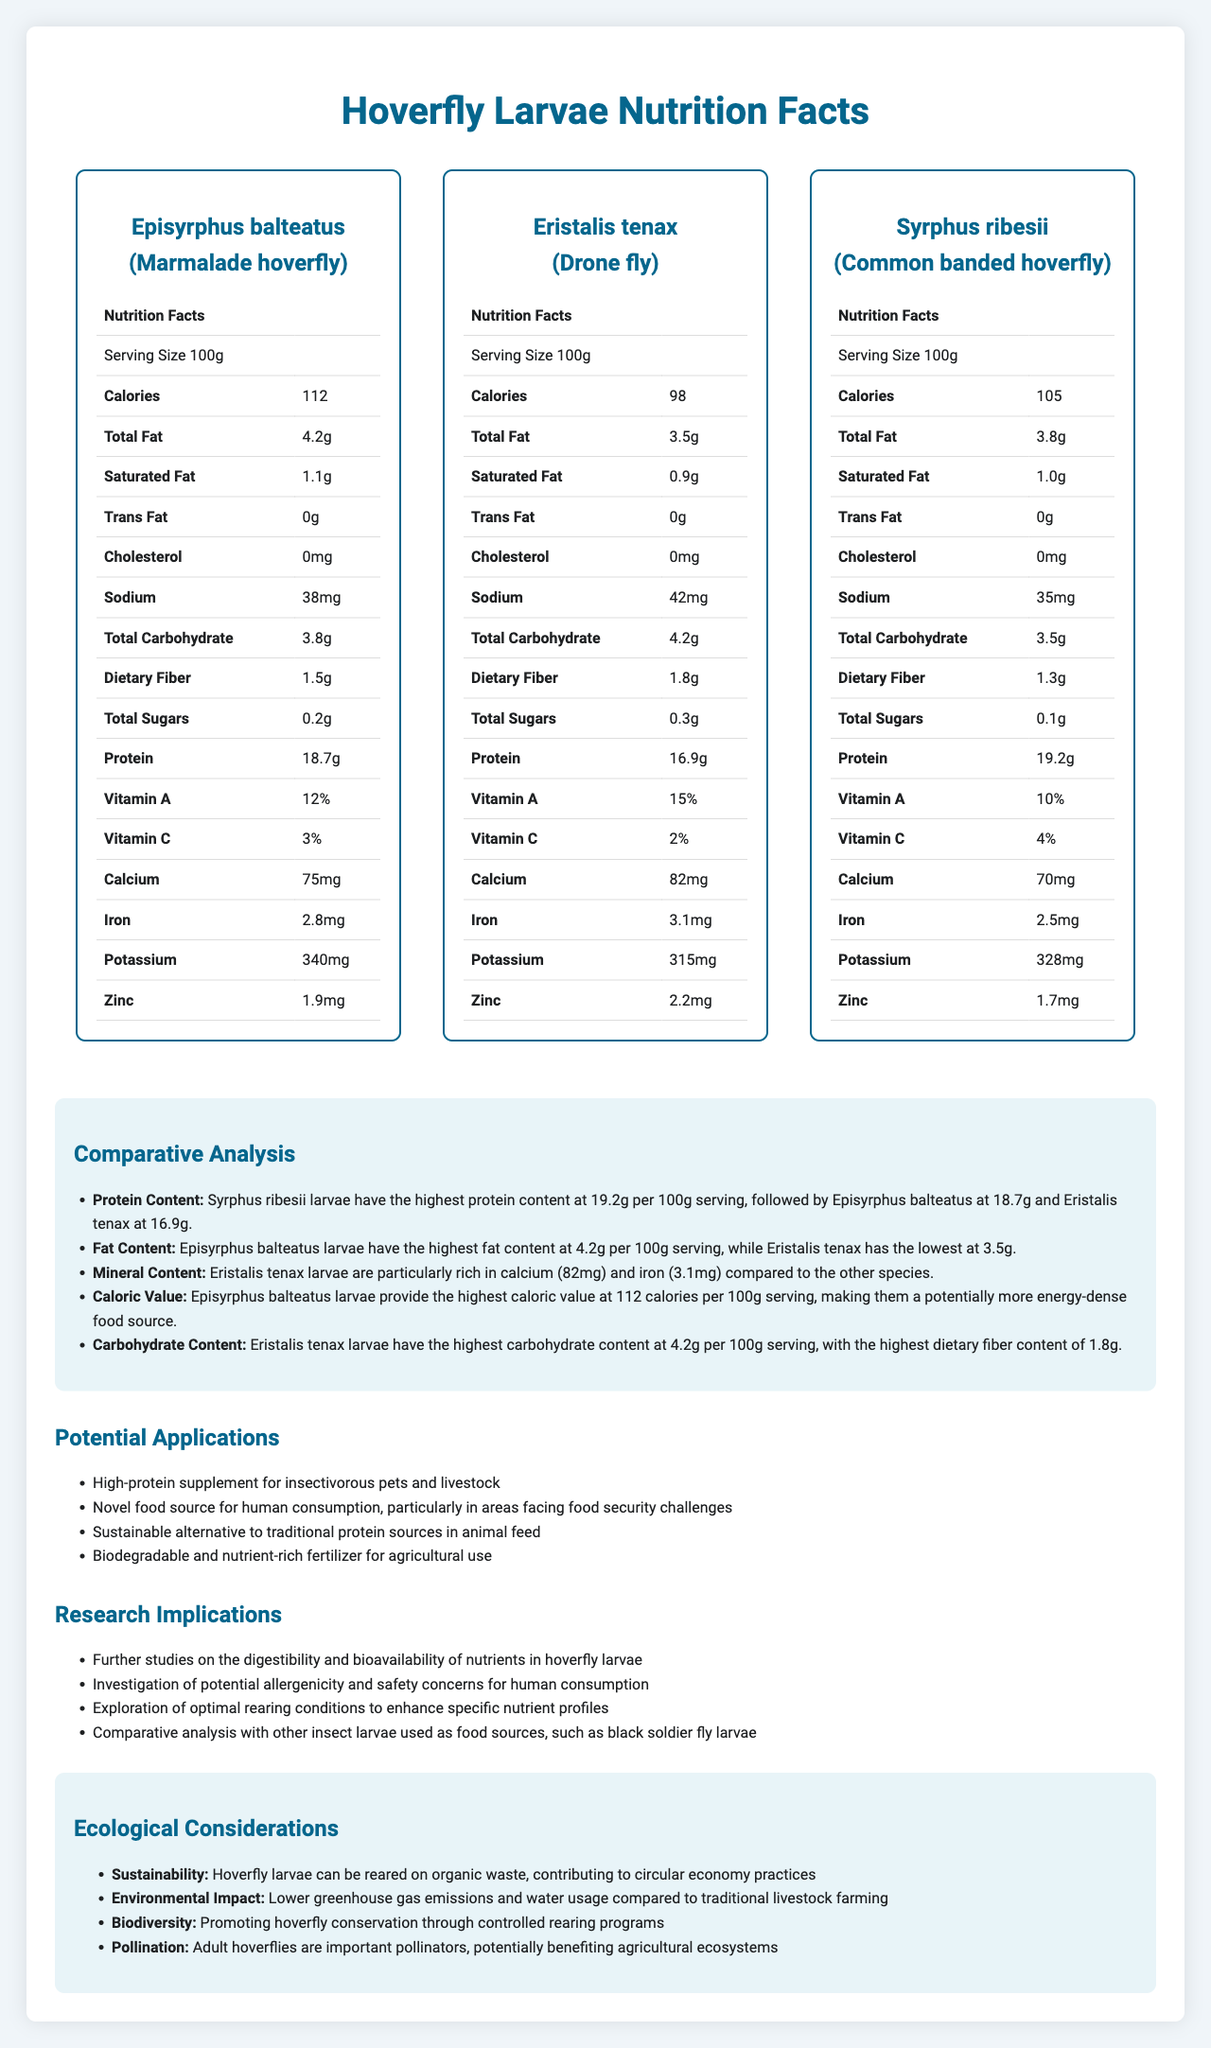what is the highest protein content among the hoverfly larvae species per 100g serving? Syrphus ribesii larvae have the highest protein content at 19.2g per 100g serving.
Answer: 19.2g which hoverfly species provides the highest caloric value per 100g serving? Episyrphus balteatus larvae provide the highest caloric value at 112 calories per 100g serving.
Answer: Episyrphus balteatus what is the total fat content of Eristalis tenax larvae per 100g serving? The total fat content of Eristalis tenax larvae is 3.5g per 100g serving.
Answer: 3.5g compared to other species, which one has the highest dietary fiber content per 100g serving? Eristalis tenax larvae have the highest dietary fiber content of 1.8g per 100g serving.
Answer: Eristalis tenax which vitamin content is highest in the Eristalis tenax larvae? A. Vitamin A B. Vitamin C The Eristalis tenax larvae contain the highest vitamin content in Vitamin A, accounting for 15%.
Answer: A. Vitamin A true or false: Episyrphus balteatus larvae have the highest carbohydrate content per 100g serving. Eristalis tenax larvae have the highest carbohydrate content at 4.2g per 100g serving, not Episyrphus balteatus.
Answer: False which hoverfly species larvae are particularly rich in calcium and iron? The comparative analysis highlighted that Eristalis tenax larvae are particularly rich in calcium (82mg) and iron (3.1mg).
Answer: Eristalis tenax which hoverfly species has the lowest total fat content per 100g serving? Eristalis tenax larvae have the lowest total fat content at 3.5g per 100g serving.
Answer: Eristalis tenax which nutrient is not listed in the nutrition facts of the hoverfly species? The document lists various nutrients such as Vitamins A and C, calcium, iron, etc., but Vitamin E is not mentioned.
Answer: Vitamin E summarize the comparative nutrient analysis of different species of hoverfly larvae. This document comprehensively compares the nutrient profiles of hoverfly larvae species, lists potential applications and research implications, and outlines ecological considerations relevant to sustainability and biodiversity.
Answer: The document provides a comparative nutrient analysis of three hoverfly species larvae: Episyrphus balteatus, Eristalis tenax, and Syrphus ribesii, highlighting their nutrition facts, including calorie, fat, protein, vitamin, and mineral content. It discusses potential applications for human and animal consumption, sustainable farming, and ecological benefits. what are the potential research implications mentioned in the document? The specific research implications mentioned, such as digestibility studies and allergenicity investigations, cannot be determined solely from the visual document.
Answer: I don't know which hoverfly species has the highest calorie count? 1. Episyrphus balteatus 2. Eristalis tenax 3. Syrphus ribesii 4. All have equal calorie count Episyrphus balteatus larvae have the highest calorie count at 112 calories per 100g serving.
Answer: 1. Episyrphus balteatus does Syrphus ribesii have the highest zinc content among the three hoverfly larvae species? Eristalis tenax has the highest zinc content at 2.2mg per 100g serving, while Syrphus ribesii has 1.7mg.
Answer: No 